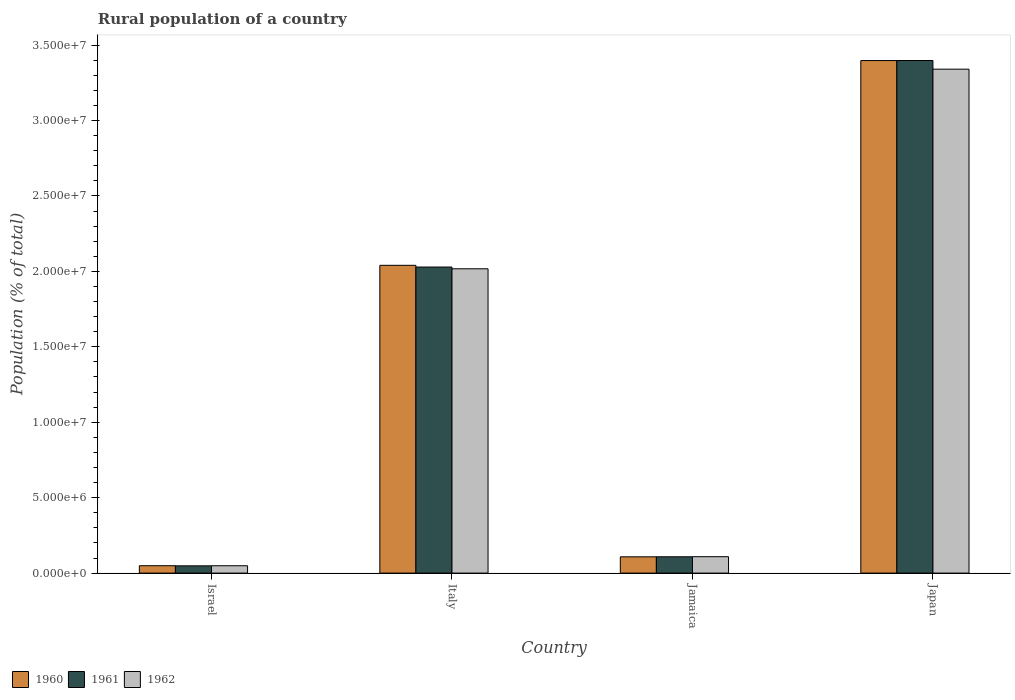Are the number of bars per tick equal to the number of legend labels?
Your response must be concise. Yes. How many bars are there on the 4th tick from the right?
Give a very brief answer. 3. In how many cases, is the number of bars for a given country not equal to the number of legend labels?
Your answer should be compact. 0. What is the rural population in 1960 in Italy?
Provide a short and direct response. 2.04e+07. Across all countries, what is the maximum rural population in 1961?
Offer a terse response. 3.40e+07. Across all countries, what is the minimum rural population in 1960?
Keep it short and to the point. 4.89e+05. What is the total rural population in 1961 in the graph?
Give a very brief answer. 5.58e+07. What is the difference between the rural population in 1961 in Italy and that in Jamaica?
Provide a succinct answer. 1.92e+07. What is the difference between the rural population in 1962 in Italy and the rural population in 1960 in Israel?
Provide a succinct answer. 1.97e+07. What is the average rural population in 1962 per country?
Provide a succinct answer. 1.38e+07. What is the difference between the rural population of/in 1961 and rural population of/in 1962 in Italy?
Ensure brevity in your answer.  1.16e+05. What is the ratio of the rural population in 1962 in Italy to that in Japan?
Give a very brief answer. 0.6. Is the rural population in 1961 in Israel less than that in Japan?
Provide a succinct answer. Yes. What is the difference between the highest and the second highest rural population in 1962?
Offer a terse response. -3.23e+07. What is the difference between the highest and the lowest rural population in 1962?
Your answer should be very brief. 3.29e+07. What does the 1st bar from the left in Israel represents?
Keep it short and to the point. 1960. What does the 2nd bar from the right in Italy represents?
Give a very brief answer. 1961. Is it the case that in every country, the sum of the rural population in 1962 and rural population in 1961 is greater than the rural population in 1960?
Your response must be concise. Yes. Are all the bars in the graph horizontal?
Your answer should be compact. No. Are the values on the major ticks of Y-axis written in scientific E-notation?
Give a very brief answer. Yes. Does the graph contain any zero values?
Your answer should be compact. No. Does the graph contain grids?
Offer a terse response. No. Where does the legend appear in the graph?
Ensure brevity in your answer.  Bottom left. How are the legend labels stacked?
Offer a terse response. Horizontal. What is the title of the graph?
Provide a succinct answer. Rural population of a country. Does "2007" appear as one of the legend labels in the graph?
Offer a very short reply. No. What is the label or title of the Y-axis?
Your answer should be compact. Population (% of total). What is the Population (% of total) of 1960 in Israel?
Give a very brief answer. 4.89e+05. What is the Population (% of total) of 1961 in Israel?
Your answer should be very brief. 4.81e+05. What is the Population (% of total) in 1962 in Israel?
Make the answer very short. 4.87e+05. What is the Population (% of total) of 1960 in Italy?
Your answer should be compact. 2.04e+07. What is the Population (% of total) of 1961 in Italy?
Your response must be concise. 2.03e+07. What is the Population (% of total) in 1962 in Italy?
Your answer should be very brief. 2.02e+07. What is the Population (% of total) of 1960 in Jamaica?
Provide a succinct answer. 1.08e+06. What is the Population (% of total) in 1961 in Jamaica?
Offer a terse response. 1.08e+06. What is the Population (% of total) of 1962 in Jamaica?
Provide a succinct answer. 1.09e+06. What is the Population (% of total) in 1960 in Japan?
Ensure brevity in your answer.  3.40e+07. What is the Population (% of total) in 1961 in Japan?
Your answer should be very brief. 3.40e+07. What is the Population (% of total) in 1962 in Japan?
Your answer should be compact. 3.34e+07. Across all countries, what is the maximum Population (% of total) of 1960?
Make the answer very short. 3.40e+07. Across all countries, what is the maximum Population (% of total) in 1961?
Offer a very short reply. 3.40e+07. Across all countries, what is the maximum Population (% of total) of 1962?
Ensure brevity in your answer.  3.34e+07. Across all countries, what is the minimum Population (% of total) in 1960?
Your answer should be compact. 4.89e+05. Across all countries, what is the minimum Population (% of total) of 1961?
Provide a short and direct response. 4.81e+05. Across all countries, what is the minimum Population (% of total) in 1962?
Offer a very short reply. 4.87e+05. What is the total Population (% of total) in 1960 in the graph?
Your answer should be compact. 5.59e+07. What is the total Population (% of total) in 1961 in the graph?
Your answer should be compact. 5.58e+07. What is the total Population (% of total) of 1962 in the graph?
Give a very brief answer. 5.51e+07. What is the difference between the Population (% of total) in 1960 in Israel and that in Italy?
Your response must be concise. -1.99e+07. What is the difference between the Population (% of total) in 1961 in Israel and that in Italy?
Ensure brevity in your answer.  -1.98e+07. What is the difference between the Population (% of total) of 1962 in Israel and that in Italy?
Your answer should be compact. -1.97e+07. What is the difference between the Population (% of total) in 1960 in Israel and that in Jamaica?
Provide a short and direct response. -5.89e+05. What is the difference between the Population (% of total) in 1961 in Israel and that in Jamaica?
Make the answer very short. -6.01e+05. What is the difference between the Population (% of total) of 1962 in Israel and that in Jamaica?
Your answer should be compact. -6.00e+05. What is the difference between the Population (% of total) in 1960 in Israel and that in Japan?
Give a very brief answer. -3.35e+07. What is the difference between the Population (% of total) in 1961 in Israel and that in Japan?
Provide a succinct answer. -3.35e+07. What is the difference between the Population (% of total) of 1962 in Israel and that in Japan?
Keep it short and to the point. -3.29e+07. What is the difference between the Population (% of total) in 1960 in Italy and that in Jamaica?
Keep it short and to the point. 1.93e+07. What is the difference between the Population (% of total) in 1961 in Italy and that in Jamaica?
Provide a short and direct response. 1.92e+07. What is the difference between the Population (% of total) in 1962 in Italy and that in Jamaica?
Provide a short and direct response. 1.91e+07. What is the difference between the Population (% of total) in 1960 in Italy and that in Japan?
Offer a terse response. -1.36e+07. What is the difference between the Population (% of total) of 1961 in Italy and that in Japan?
Keep it short and to the point. -1.37e+07. What is the difference between the Population (% of total) in 1962 in Italy and that in Japan?
Make the answer very short. -1.32e+07. What is the difference between the Population (% of total) of 1960 in Jamaica and that in Japan?
Your answer should be very brief. -3.29e+07. What is the difference between the Population (% of total) of 1961 in Jamaica and that in Japan?
Your answer should be compact. -3.29e+07. What is the difference between the Population (% of total) of 1962 in Jamaica and that in Japan?
Offer a terse response. -3.23e+07. What is the difference between the Population (% of total) in 1960 in Israel and the Population (% of total) in 1961 in Italy?
Provide a succinct answer. -1.98e+07. What is the difference between the Population (% of total) of 1960 in Israel and the Population (% of total) of 1962 in Italy?
Give a very brief answer. -1.97e+07. What is the difference between the Population (% of total) of 1961 in Israel and the Population (% of total) of 1962 in Italy?
Your response must be concise. -1.97e+07. What is the difference between the Population (% of total) in 1960 in Israel and the Population (% of total) in 1961 in Jamaica?
Provide a short and direct response. -5.93e+05. What is the difference between the Population (% of total) in 1960 in Israel and the Population (% of total) in 1962 in Jamaica?
Your response must be concise. -5.98e+05. What is the difference between the Population (% of total) of 1961 in Israel and the Population (% of total) of 1962 in Jamaica?
Make the answer very short. -6.06e+05. What is the difference between the Population (% of total) in 1960 in Israel and the Population (% of total) in 1961 in Japan?
Your answer should be very brief. -3.35e+07. What is the difference between the Population (% of total) of 1960 in Israel and the Population (% of total) of 1962 in Japan?
Your response must be concise. -3.29e+07. What is the difference between the Population (% of total) in 1961 in Israel and the Population (% of total) in 1962 in Japan?
Provide a short and direct response. -3.29e+07. What is the difference between the Population (% of total) of 1960 in Italy and the Population (% of total) of 1961 in Jamaica?
Provide a succinct answer. 1.93e+07. What is the difference between the Population (% of total) in 1960 in Italy and the Population (% of total) in 1962 in Jamaica?
Your answer should be compact. 1.93e+07. What is the difference between the Population (% of total) of 1961 in Italy and the Population (% of total) of 1962 in Jamaica?
Offer a terse response. 1.92e+07. What is the difference between the Population (% of total) of 1960 in Italy and the Population (% of total) of 1961 in Japan?
Keep it short and to the point. -1.36e+07. What is the difference between the Population (% of total) of 1960 in Italy and the Population (% of total) of 1962 in Japan?
Keep it short and to the point. -1.30e+07. What is the difference between the Population (% of total) in 1961 in Italy and the Population (% of total) in 1962 in Japan?
Your response must be concise. -1.31e+07. What is the difference between the Population (% of total) of 1960 in Jamaica and the Population (% of total) of 1961 in Japan?
Provide a succinct answer. -3.29e+07. What is the difference between the Population (% of total) in 1960 in Jamaica and the Population (% of total) in 1962 in Japan?
Provide a succinct answer. -3.23e+07. What is the difference between the Population (% of total) of 1961 in Jamaica and the Population (% of total) of 1962 in Japan?
Your response must be concise. -3.23e+07. What is the average Population (% of total) of 1960 per country?
Keep it short and to the point. 1.40e+07. What is the average Population (% of total) in 1961 per country?
Make the answer very short. 1.40e+07. What is the average Population (% of total) of 1962 per country?
Offer a very short reply. 1.38e+07. What is the difference between the Population (% of total) in 1960 and Population (% of total) in 1961 in Israel?
Keep it short and to the point. 8410. What is the difference between the Population (% of total) of 1960 and Population (% of total) of 1962 in Israel?
Offer a terse response. 2267. What is the difference between the Population (% of total) of 1961 and Population (% of total) of 1962 in Israel?
Provide a short and direct response. -6143. What is the difference between the Population (% of total) in 1960 and Population (% of total) in 1961 in Italy?
Your answer should be very brief. 1.13e+05. What is the difference between the Population (% of total) in 1960 and Population (% of total) in 1962 in Italy?
Provide a short and direct response. 2.29e+05. What is the difference between the Population (% of total) of 1961 and Population (% of total) of 1962 in Italy?
Ensure brevity in your answer.  1.16e+05. What is the difference between the Population (% of total) of 1960 and Population (% of total) of 1961 in Jamaica?
Ensure brevity in your answer.  -3099. What is the difference between the Population (% of total) in 1960 and Population (% of total) in 1962 in Jamaica?
Give a very brief answer. -8087. What is the difference between the Population (% of total) in 1961 and Population (% of total) in 1962 in Jamaica?
Your response must be concise. -4988. What is the difference between the Population (% of total) in 1960 and Population (% of total) in 1961 in Japan?
Your answer should be compact. -3641. What is the difference between the Population (% of total) of 1960 and Population (% of total) of 1962 in Japan?
Your response must be concise. 5.70e+05. What is the difference between the Population (% of total) of 1961 and Population (% of total) of 1962 in Japan?
Offer a very short reply. 5.74e+05. What is the ratio of the Population (% of total) in 1960 in Israel to that in Italy?
Your answer should be very brief. 0.02. What is the ratio of the Population (% of total) in 1961 in Israel to that in Italy?
Provide a short and direct response. 0.02. What is the ratio of the Population (% of total) in 1962 in Israel to that in Italy?
Make the answer very short. 0.02. What is the ratio of the Population (% of total) of 1960 in Israel to that in Jamaica?
Your response must be concise. 0.45. What is the ratio of the Population (% of total) of 1961 in Israel to that in Jamaica?
Provide a short and direct response. 0.44. What is the ratio of the Population (% of total) of 1962 in Israel to that in Jamaica?
Ensure brevity in your answer.  0.45. What is the ratio of the Population (% of total) in 1960 in Israel to that in Japan?
Provide a short and direct response. 0.01. What is the ratio of the Population (% of total) in 1961 in Israel to that in Japan?
Provide a succinct answer. 0.01. What is the ratio of the Population (% of total) in 1962 in Israel to that in Japan?
Your answer should be very brief. 0.01. What is the ratio of the Population (% of total) in 1960 in Italy to that in Jamaica?
Provide a short and direct response. 18.91. What is the ratio of the Population (% of total) in 1961 in Italy to that in Jamaica?
Ensure brevity in your answer.  18.75. What is the ratio of the Population (% of total) of 1962 in Italy to that in Jamaica?
Your response must be concise. 18.56. What is the ratio of the Population (% of total) in 1960 in Italy to that in Japan?
Provide a succinct answer. 0.6. What is the ratio of the Population (% of total) of 1961 in Italy to that in Japan?
Your answer should be compact. 0.6. What is the ratio of the Population (% of total) in 1962 in Italy to that in Japan?
Offer a very short reply. 0.6. What is the ratio of the Population (% of total) of 1960 in Jamaica to that in Japan?
Give a very brief answer. 0.03. What is the ratio of the Population (% of total) of 1961 in Jamaica to that in Japan?
Make the answer very short. 0.03. What is the ratio of the Population (% of total) of 1962 in Jamaica to that in Japan?
Give a very brief answer. 0.03. What is the difference between the highest and the second highest Population (% of total) of 1960?
Keep it short and to the point. 1.36e+07. What is the difference between the highest and the second highest Population (% of total) in 1961?
Give a very brief answer. 1.37e+07. What is the difference between the highest and the second highest Population (% of total) in 1962?
Offer a very short reply. 1.32e+07. What is the difference between the highest and the lowest Population (% of total) in 1960?
Your response must be concise. 3.35e+07. What is the difference between the highest and the lowest Population (% of total) in 1961?
Keep it short and to the point. 3.35e+07. What is the difference between the highest and the lowest Population (% of total) of 1962?
Provide a short and direct response. 3.29e+07. 